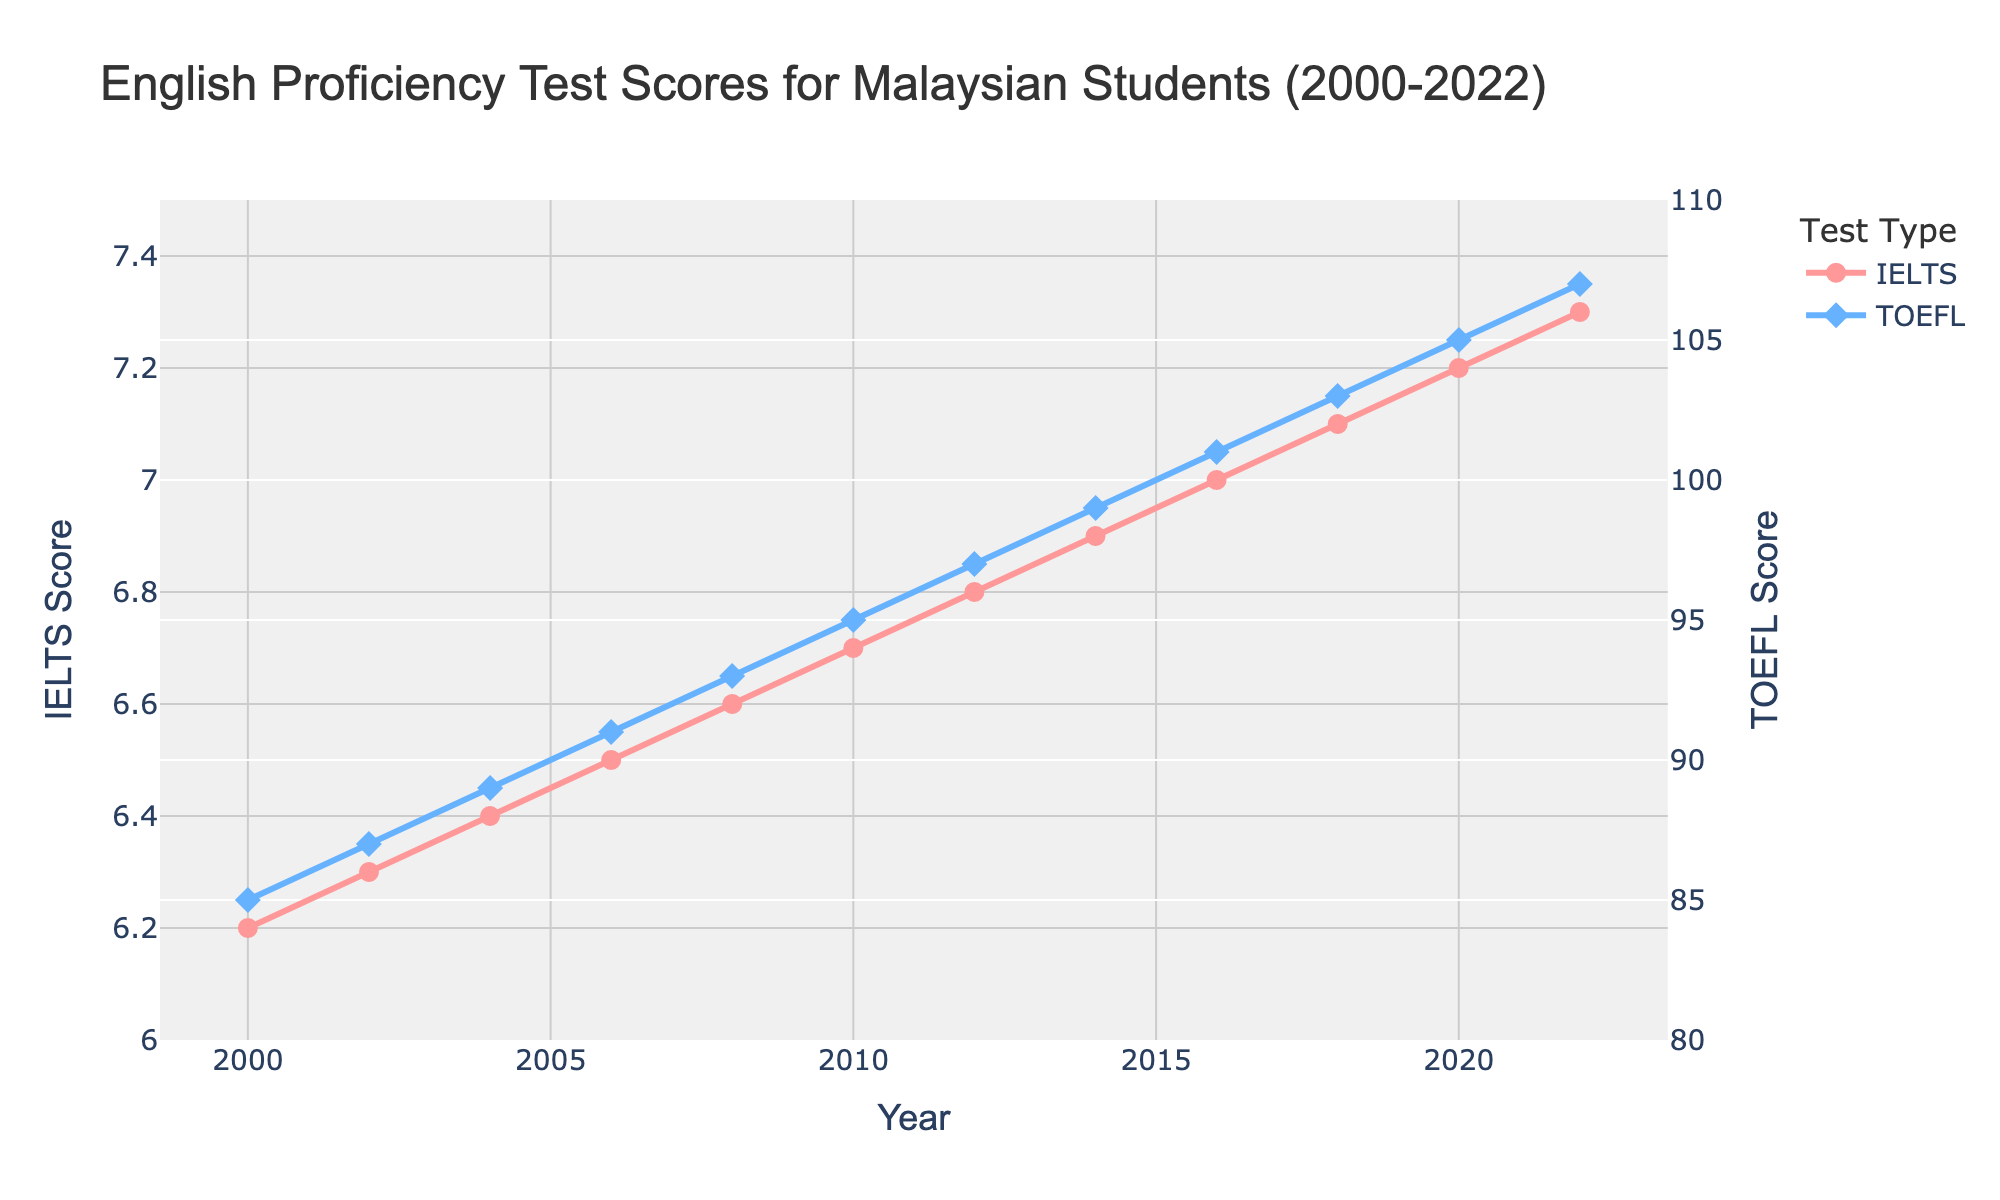What is the difference between the average IELTS score in 2000 and 2022? To find the difference between the scores in 2000 and 2022, subtract the 2000 value from the 2022 value, i.e., 7.3 - 6.2.
Answer: 1.1 How much has the average TOEFL score increased from 2004 to 2014? The average TOEFL score in 2004 is 89, and in 2014 it is 99. Subtract the 2004 value from the 2014 value to find the increase: 99 - 89.
Answer: 10 Which test, IELTS or TOEFL, shows a higher average score increase between 2000 and 2022? First, calculate the increase for both tests: IELTS: 7.3 - 6.2 = 1.1; TOEFL: 107 - 85 = 22. Comparing these results, TOEFL shows a higher increase.
Answer: TOEFL What is the general trend of the average IELTS and TOEFL scores from 2000 to 2022? Observing the data points over time, both IELTS and TOEFL scores show an upward trend as the years progress.
Answer: Upward trend In which year did the average IELTS score reach 7.0 for the first time? By looking at the average IELTS score data, 2016 is the year where the average IELTS score is 7.0.
Answer: 2016 Which year showed the same rate of change in scores for both IELTS and TOEFL compared to the previous year? To determine this, observe the data closely. Between 2014 and 2016, both IELTS and TOEFL scores increased by exactly 1 point: IELTS from 6.9 to 7.0 and TOEFL from 99 to 101.
Answer: 2016 What is the total increase in average IELTS scores from 2000 to 2022? Calculate the difference between the 2022 and 2000 average IELTS scores: 7.3 - 6.2.
Answer: 1.1 How does the pattern of average TOEFL score changes compare to average IELTS score changes over the entire period? Both the TOEFL and IELTS scores show a linear increase over the years, but TOEFL scores have a larger range of increase.
Answer: Linear, TOEFL has a larger range By how much did the average TOEFL score change per year on average from 2000 to 2022? First calculate the total change over the period: 107 - 85 = 22. Next, divide by the number of years (2022 - 2000 = 22 years): 22 / 22.
Answer: 1 In which period did the average IELTS score increase the least amount, and what was the increment? To determine this, look at the yearly increments. The smallest increment is between 2002 and 2004 with an increment of 0.1 (from 6.3 to 6.4).
Answer: 2002-2004, 0.1 